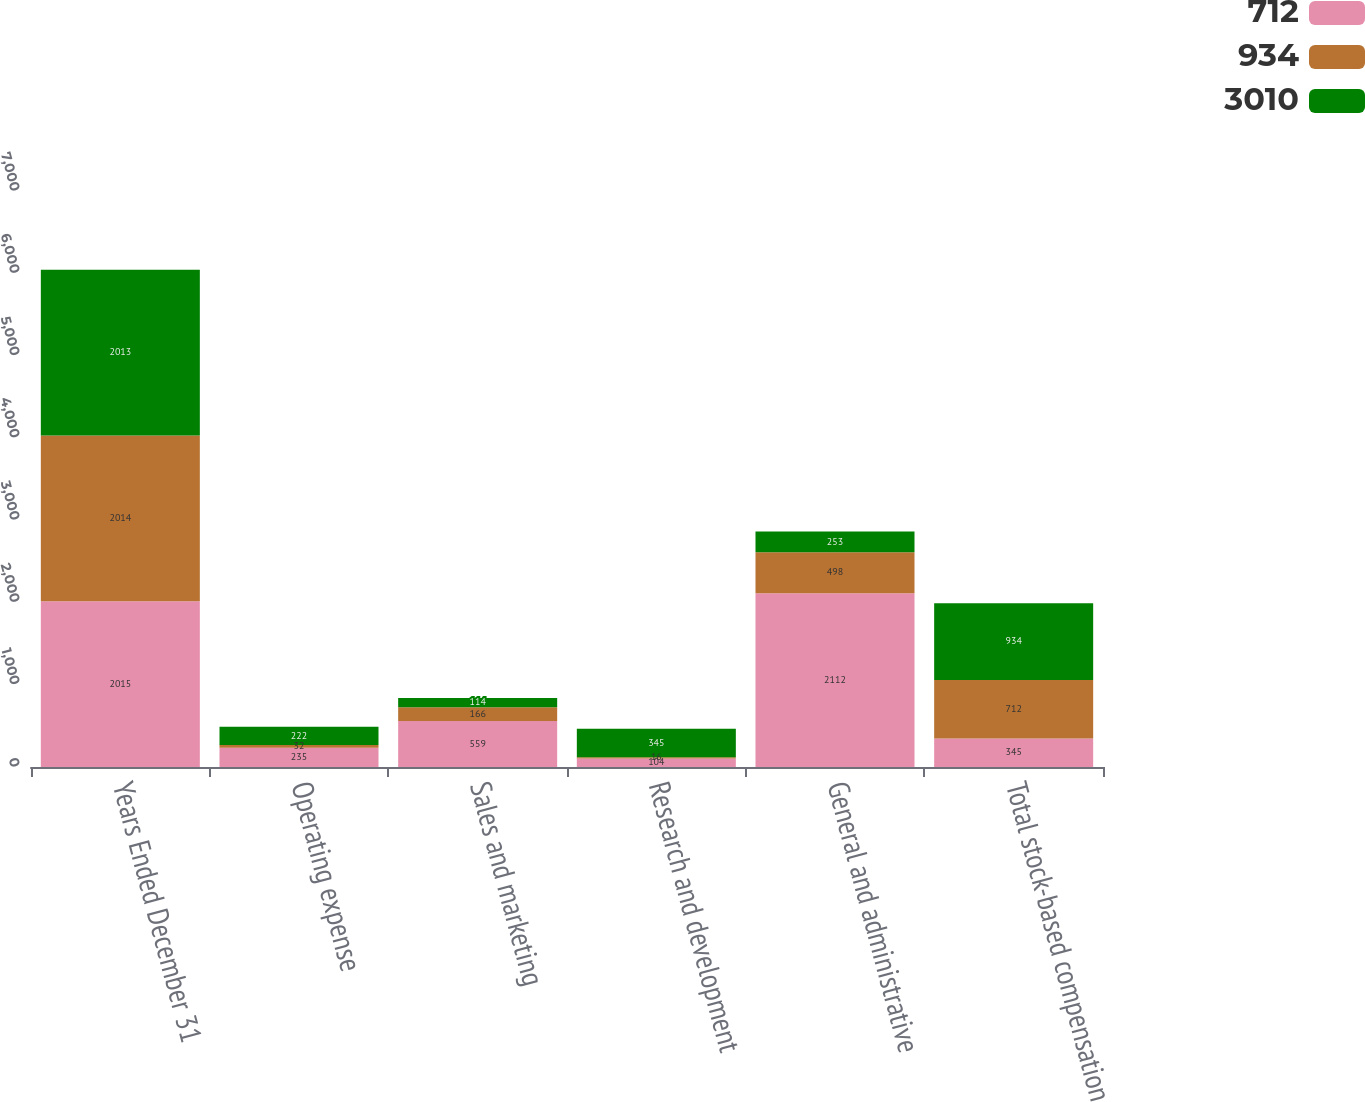Convert chart. <chart><loc_0><loc_0><loc_500><loc_500><stacked_bar_chart><ecel><fcel>Years Ended December 31<fcel>Operating expense<fcel>Sales and marketing<fcel>Research and development<fcel>General and administrative<fcel>Total stock-based compensation<nl><fcel>712<fcel>2015<fcel>235<fcel>559<fcel>104<fcel>2112<fcel>345<nl><fcel>934<fcel>2014<fcel>32<fcel>166<fcel>16<fcel>498<fcel>712<nl><fcel>3010<fcel>2013<fcel>222<fcel>114<fcel>345<fcel>253<fcel>934<nl></chart> 